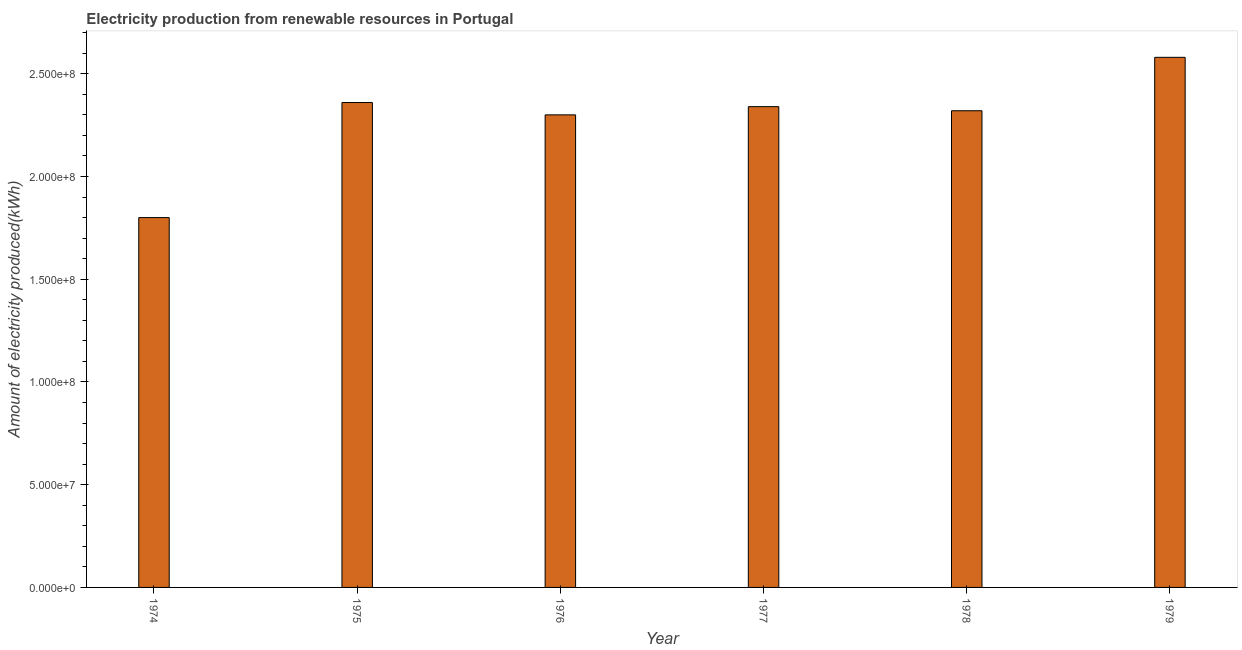Does the graph contain grids?
Your answer should be very brief. No. What is the title of the graph?
Keep it short and to the point. Electricity production from renewable resources in Portugal. What is the label or title of the X-axis?
Your answer should be very brief. Year. What is the label or title of the Y-axis?
Your response must be concise. Amount of electricity produced(kWh). What is the amount of electricity produced in 1975?
Offer a very short reply. 2.36e+08. Across all years, what is the maximum amount of electricity produced?
Keep it short and to the point. 2.58e+08. Across all years, what is the minimum amount of electricity produced?
Offer a terse response. 1.80e+08. In which year was the amount of electricity produced maximum?
Provide a short and direct response. 1979. In which year was the amount of electricity produced minimum?
Your answer should be very brief. 1974. What is the sum of the amount of electricity produced?
Keep it short and to the point. 1.37e+09. What is the difference between the amount of electricity produced in 1976 and 1978?
Make the answer very short. -2.00e+06. What is the average amount of electricity produced per year?
Your response must be concise. 2.28e+08. What is the median amount of electricity produced?
Your answer should be very brief. 2.33e+08. In how many years, is the amount of electricity produced greater than 180000000 kWh?
Offer a very short reply. 5. What is the ratio of the amount of electricity produced in 1976 to that in 1979?
Your answer should be compact. 0.89. Is the amount of electricity produced in 1974 less than that in 1976?
Provide a succinct answer. Yes. What is the difference between the highest and the second highest amount of electricity produced?
Keep it short and to the point. 2.20e+07. What is the difference between the highest and the lowest amount of electricity produced?
Provide a short and direct response. 7.80e+07. How many bars are there?
Provide a succinct answer. 6. How many years are there in the graph?
Provide a short and direct response. 6. What is the difference between two consecutive major ticks on the Y-axis?
Offer a terse response. 5.00e+07. Are the values on the major ticks of Y-axis written in scientific E-notation?
Your answer should be very brief. Yes. What is the Amount of electricity produced(kWh) in 1974?
Your response must be concise. 1.80e+08. What is the Amount of electricity produced(kWh) in 1975?
Give a very brief answer. 2.36e+08. What is the Amount of electricity produced(kWh) in 1976?
Provide a succinct answer. 2.30e+08. What is the Amount of electricity produced(kWh) of 1977?
Your answer should be very brief. 2.34e+08. What is the Amount of electricity produced(kWh) in 1978?
Make the answer very short. 2.32e+08. What is the Amount of electricity produced(kWh) in 1979?
Provide a succinct answer. 2.58e+08. What is the difference between the Amount of electricity produced(kWh) in 1974 and 1975?
Make the answer very short. -5.60e+07. What is the difference between the Amount of electricity produced(kWh) in 1974 and 1976?
Keep it short and to the point. -5.00e+07. What is the difference between the Amount of electricity produced(kWh) in 1974 and 1977?
Offer a very short reply. -5.40e+07. What is the difference between the Amount of electricity produced(kWh) in 1974 and 1978?
Give a very brief answer. -5.20e+07. What is the difference between the Amount of electricity produced(kWh) in 1974 and 1979?
Provide a succinct answer. -7.80e+07. What is the difference between the Amount of electricity produced(kWh) in 1975 and 1977?
Provide a short and direct response. 2.00e+06. What is the difference between the Amount of electricity produced(kWh) in 1975 and 1978?
Keep it short and to the point. 4.00e+06. What is the difference between the Amount of electricity produced(kWh) in 1975 and 1979?
Your answer should be compact. -2.20e+07. What is the difference between the Amount of electricity produced(kWh) in 1976 and 1977?
Your answer should be very brief. -4.00e+06. What is the difference between the Amount of electricity produced(kWh) in 1976 and 1979?
Give a very brief answer. -2.80e+07. What is the difference between the Amount of electricity produced(kWh) in 1977 and 1979?
Offer a very short reply. -2.40e+07. What is the difference between the Amount of electricity produced(kWh) in 1978 and 1979?
Provide a succinct answer. -2.60e+07. What is the ratio of the Amount of electricity produced(kWh) in 1974 to that in 1975?
Your answer should be compact. 0.76. What is the ratio of the Amount of electricity produced(kWh) in 1974 to that in 1976?
Make the answer very short. 0.78. What is the ratio of the Amount of electricity produced(kWh) in 1974 to that in 1977?
Keep it short and to the point. 0.77. What is the ratio of the Amount of electricity produced(kWh) in 1974 to that in 1978?
Your response must be concise. 0.78. What is the ratio of the Amount of electricity produced(kWh) in 1974 to that in 1979?
Provide a short and direct response. 0.7. What is the ratio of the Amount of electricity produced(kWh) in 1975 to that in 1976?
Provide a short and direct response. 1.03. What is the ratio of the Amount of electricity produced(kWh) in 1975 to that in 1977?
Your response must be concise. 1.01. What is the ratio of the Amount of electricity produced(kWh) in 1975 to that in 1979?
Keep it short and to the point. 0.92. What is the ratio of the Amount of electricity produced(kWh) in 1976 to that in 1978?
Ensure brevity in your answer.  0.99. What is the ratio of the Amount of electricity produced(kWh) in 1976 to that in 1979?
Keep it short and to the point. 0.89. What is the ratio of the Amount of electricity produced(kWh) in 1977 to that in 1978?
Make the answer very short. 1.01. What is the ratio of the Amount of electricity produced(kWh) in 1977 to that in 1979?
Give a very brief answer. 0.91. What is the ratio of the Amount of electricity produced(kWh) in 1978 to that in 1979?
Provide a succinct answer. 0.9. 